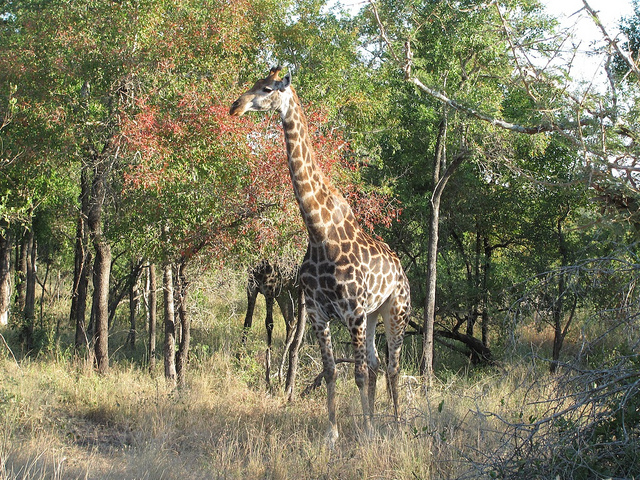Can you describe the habitat in which this giraffe lives? The giraffe is standing in a woodland habitat, typical of the savannas where giraffes commonly reside. The trees provide both shade and food, and the open spaces facilitate the giraffe’s ability to spot predators at a distance. 